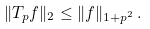<formula> <loc_0><loc_0><loc_500><loc_500>\| T _ { p } f \| _ { 2 } \leq \| f \| _ { 1 + p ^ { 2 } } \, .</formula> 